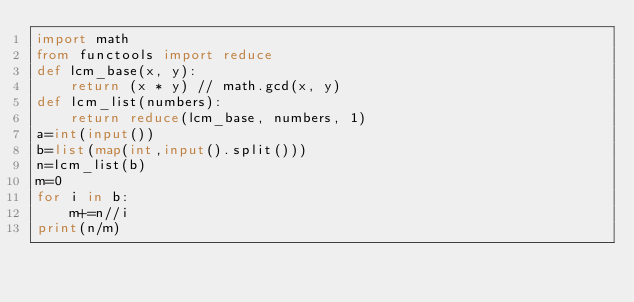<code> <loc_0><loc_0><loc_500><loc_500><_Python_>import math
from functools import reduce
def lcm_base(x, y):
    return (x * y) // math.gcd(x, y)
def lcm_list(numbers):
    return reduce(lcm_base, numbers, 1)
a=int(input())
b=list(map(int,input().split()))
n=lcm_list(b)
m=0
for i in b:
    m+=n//i
print(n/m)</code> 